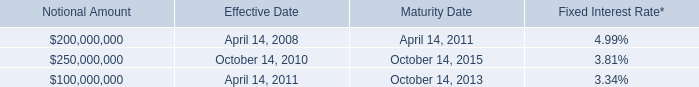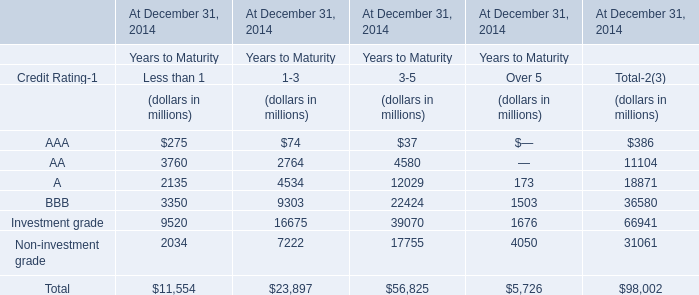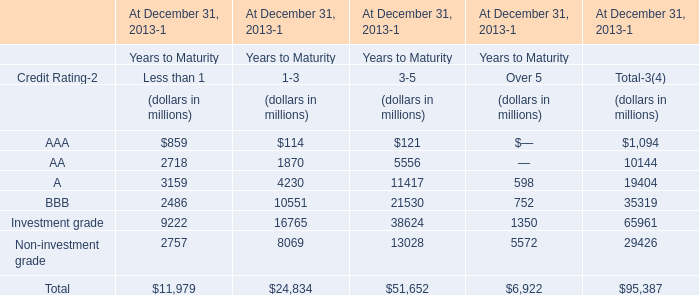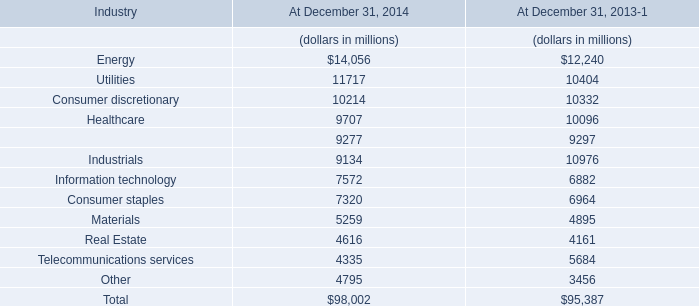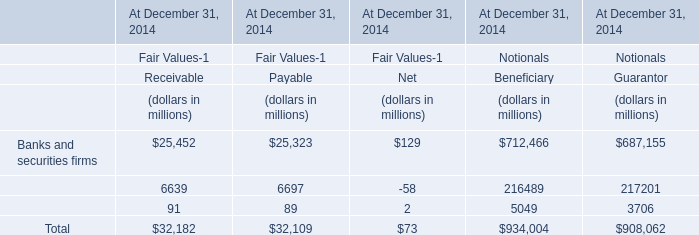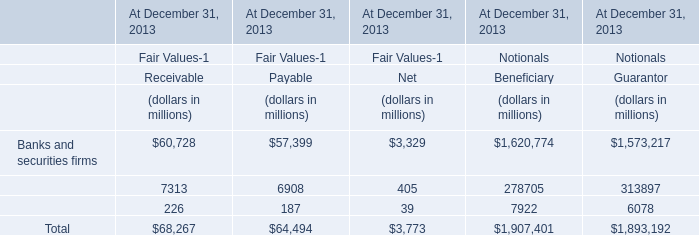What is the average value of BBB for Less than 1,1-3 and 3-5 ? (in million) 
Computations: (((3350 + 9303) + 22424) / 3)
Answer: 11692.33333. 